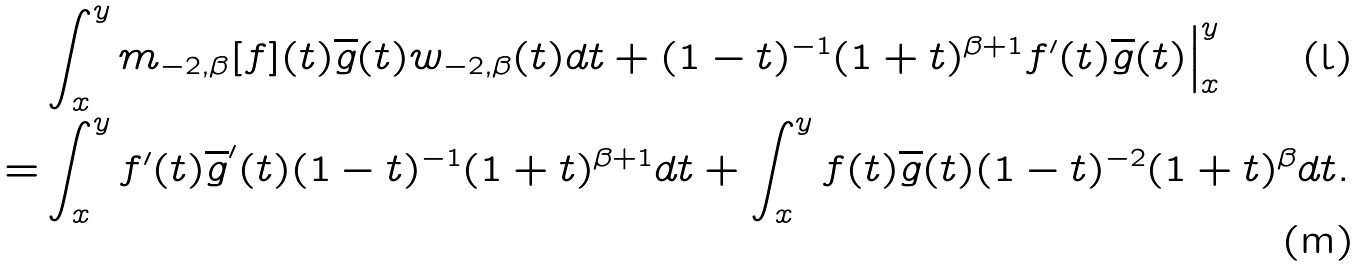<formula> <loc_0><loc_0><loc_500><loc_500>& \int _ { x } ^ { y } m _ { - 2 , \beta } [ f ] ( t ) \overline { g } ( t ) w _ { - 2 , \beta } ( t ) d t + ( 1 - t ) ^ { - 1 } ( 1 + t ) ^ { \beta + 1 } f ^ { \prime } ( t ) \overline { g } ( t ) \Big | _ { x } ^ { y } \\ = & \int _ { x } ^ { y } f ^ { \prime } ( t ) \overline { g } ^ { \prime } ( t ) ( 1 - t ) ^ { - 1 } ( 1 + t ) ^ { \beta + 1 } d t + \int _ { x } ^ { y } f ( t ) \overline { g } ( t ) ( 1 - t ) ^ { - 2 } ( 1 + t ) ^ { \beta } d t .</formula> 